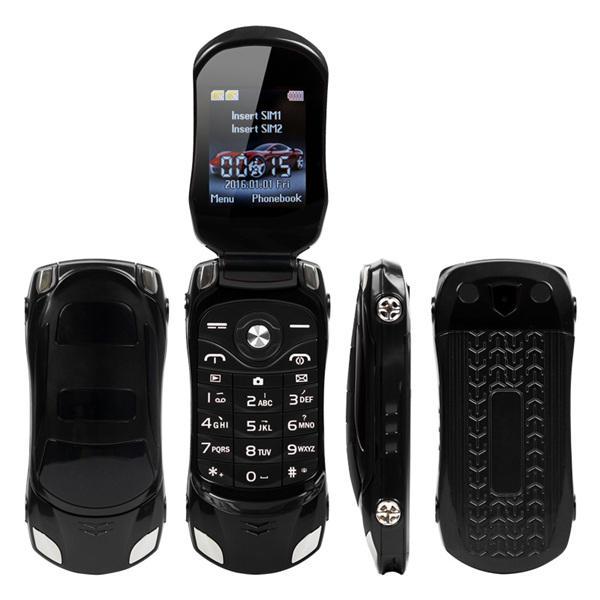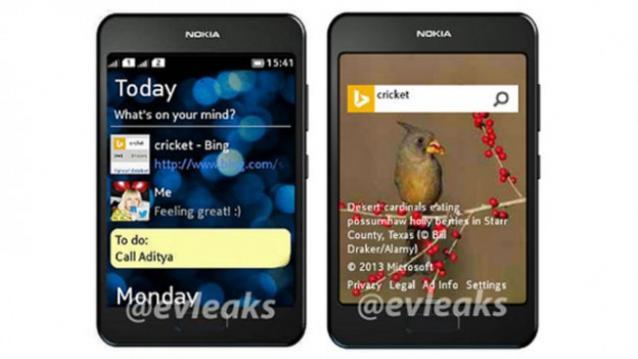The first image is the image on the left, the second image is the image on the right. Given the left and right images, does the statement "One of the phones has physical keys." hold true? Answer yes or no. Yes. The first image is the image on the left, the second image is the image on the right. Examine the images to the left and right. Is the description "One image shows three screened devices in a row, and each image includes rainbow colors in a curving ribbon shape on at least one screen." accurate? Answer yes or no. No. 